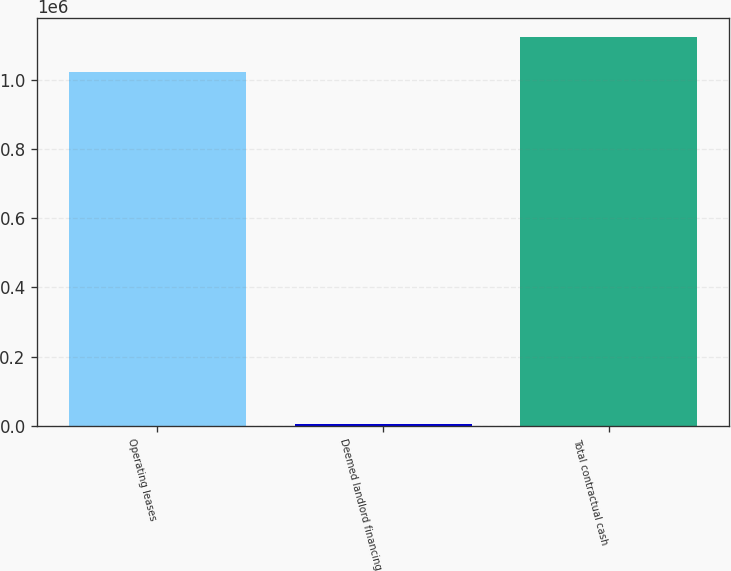Convert chart to OTSL. <chart><loc_0><loc_0><loc_500><loc_500><bar_chart><fcel>Operating leases<fcel>Deemed landlord financing<fcel>Total contractual cash<nl><fcel>1.02085e+06<fcel>5504<fcel>1.12294e+06<nl></chart> 